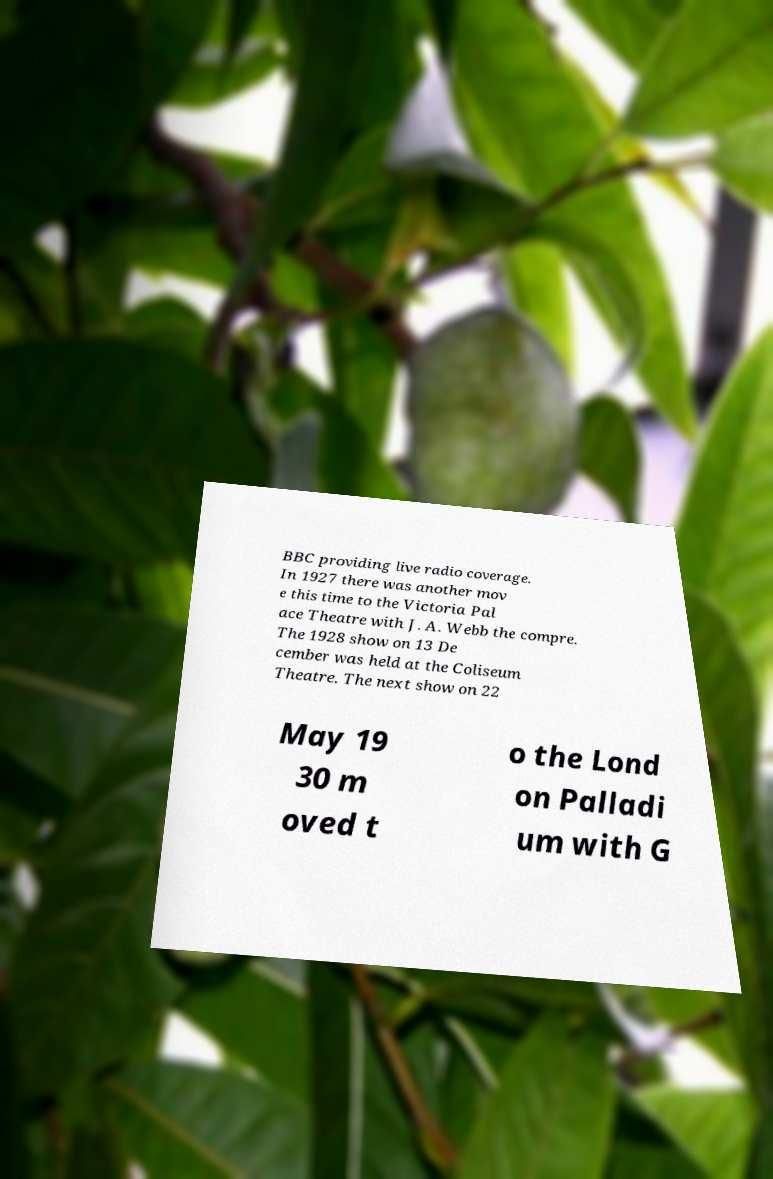For documentation purposes, I need the text within this image transcribed. Could you provide that? BBC providing live radio coverage. In 1927 there was another mov e this time to the Victoria Pal ace Theatre with J. A. Webb the compre. The 1928 show on 13 De cember was held at the Coliseum Theatre. The next show on 22 May 19 30 m oved t o the Lond on Palladi um with G 